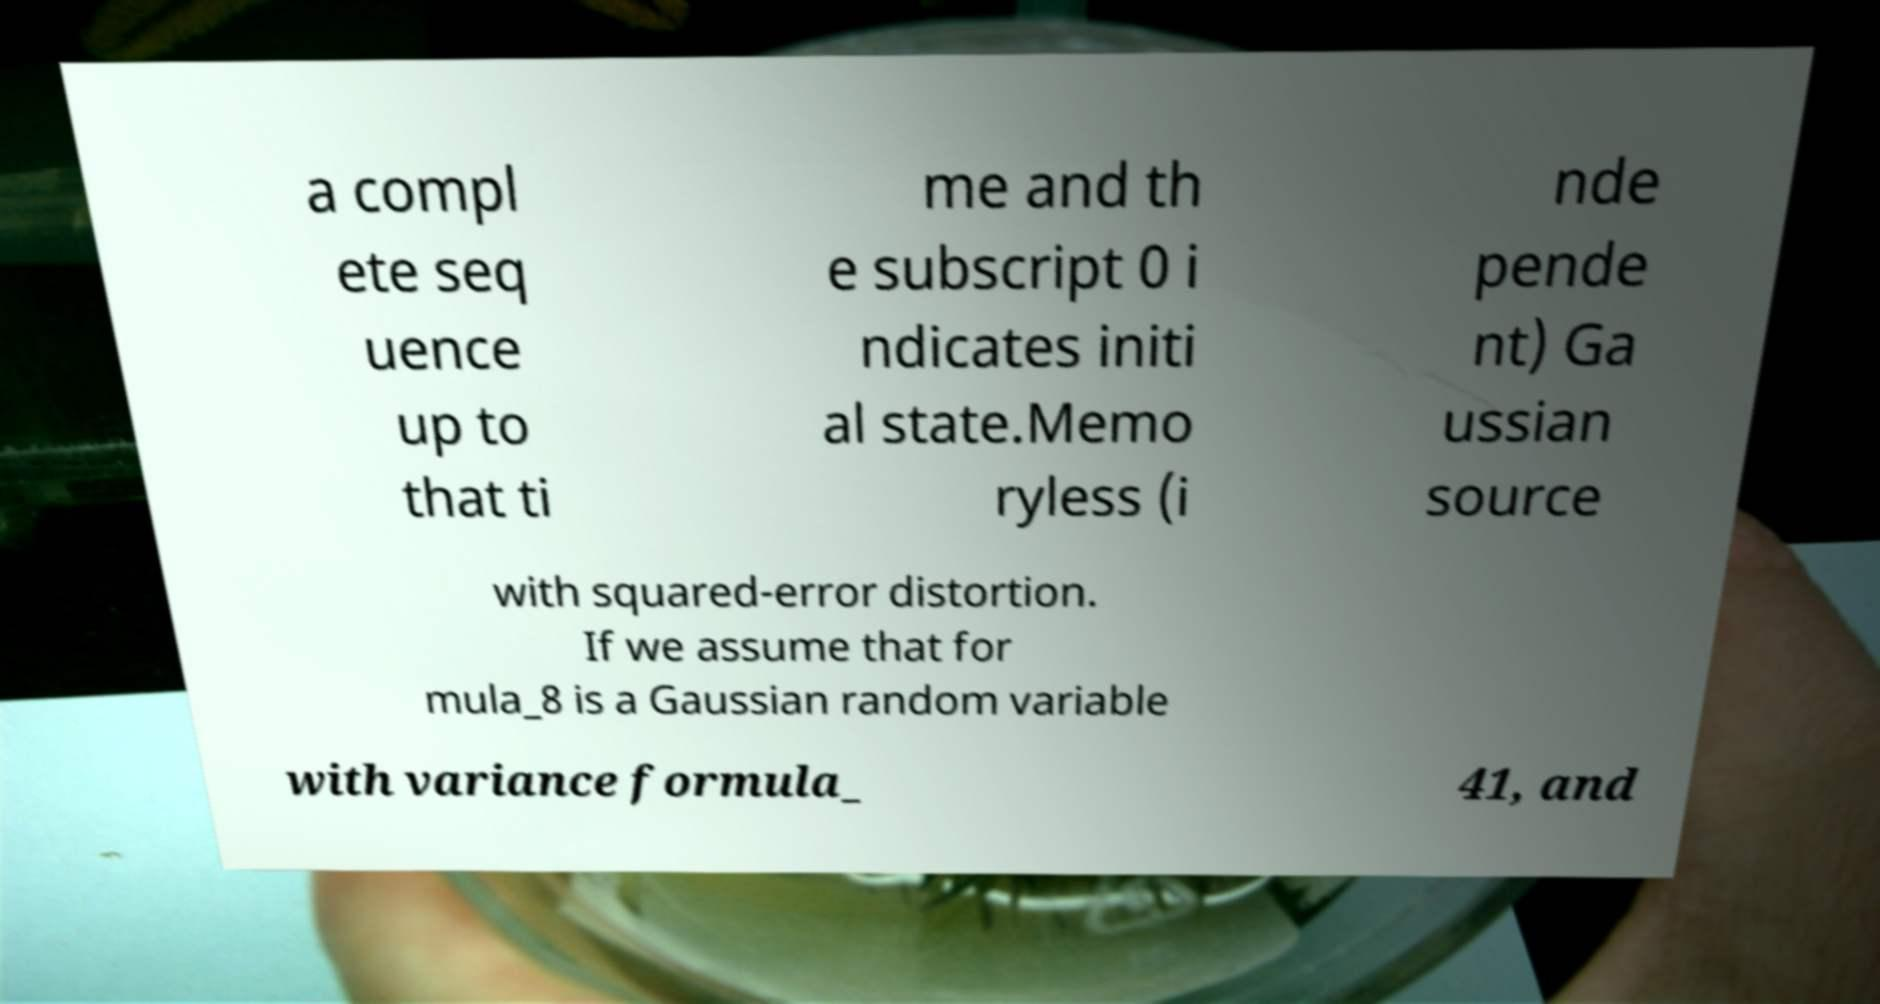Could you assist in decoding the text presented in this image and type it out clearly? a compl ete seq uence up to that ti me and th e subscript 0 i ndicates initi al state.Memo ryless (i nde pende nt) Ga ussian source with squared-error distortion. If we assume that for mula_8 is a Gaussian random variable with variance formula_ 41, and 